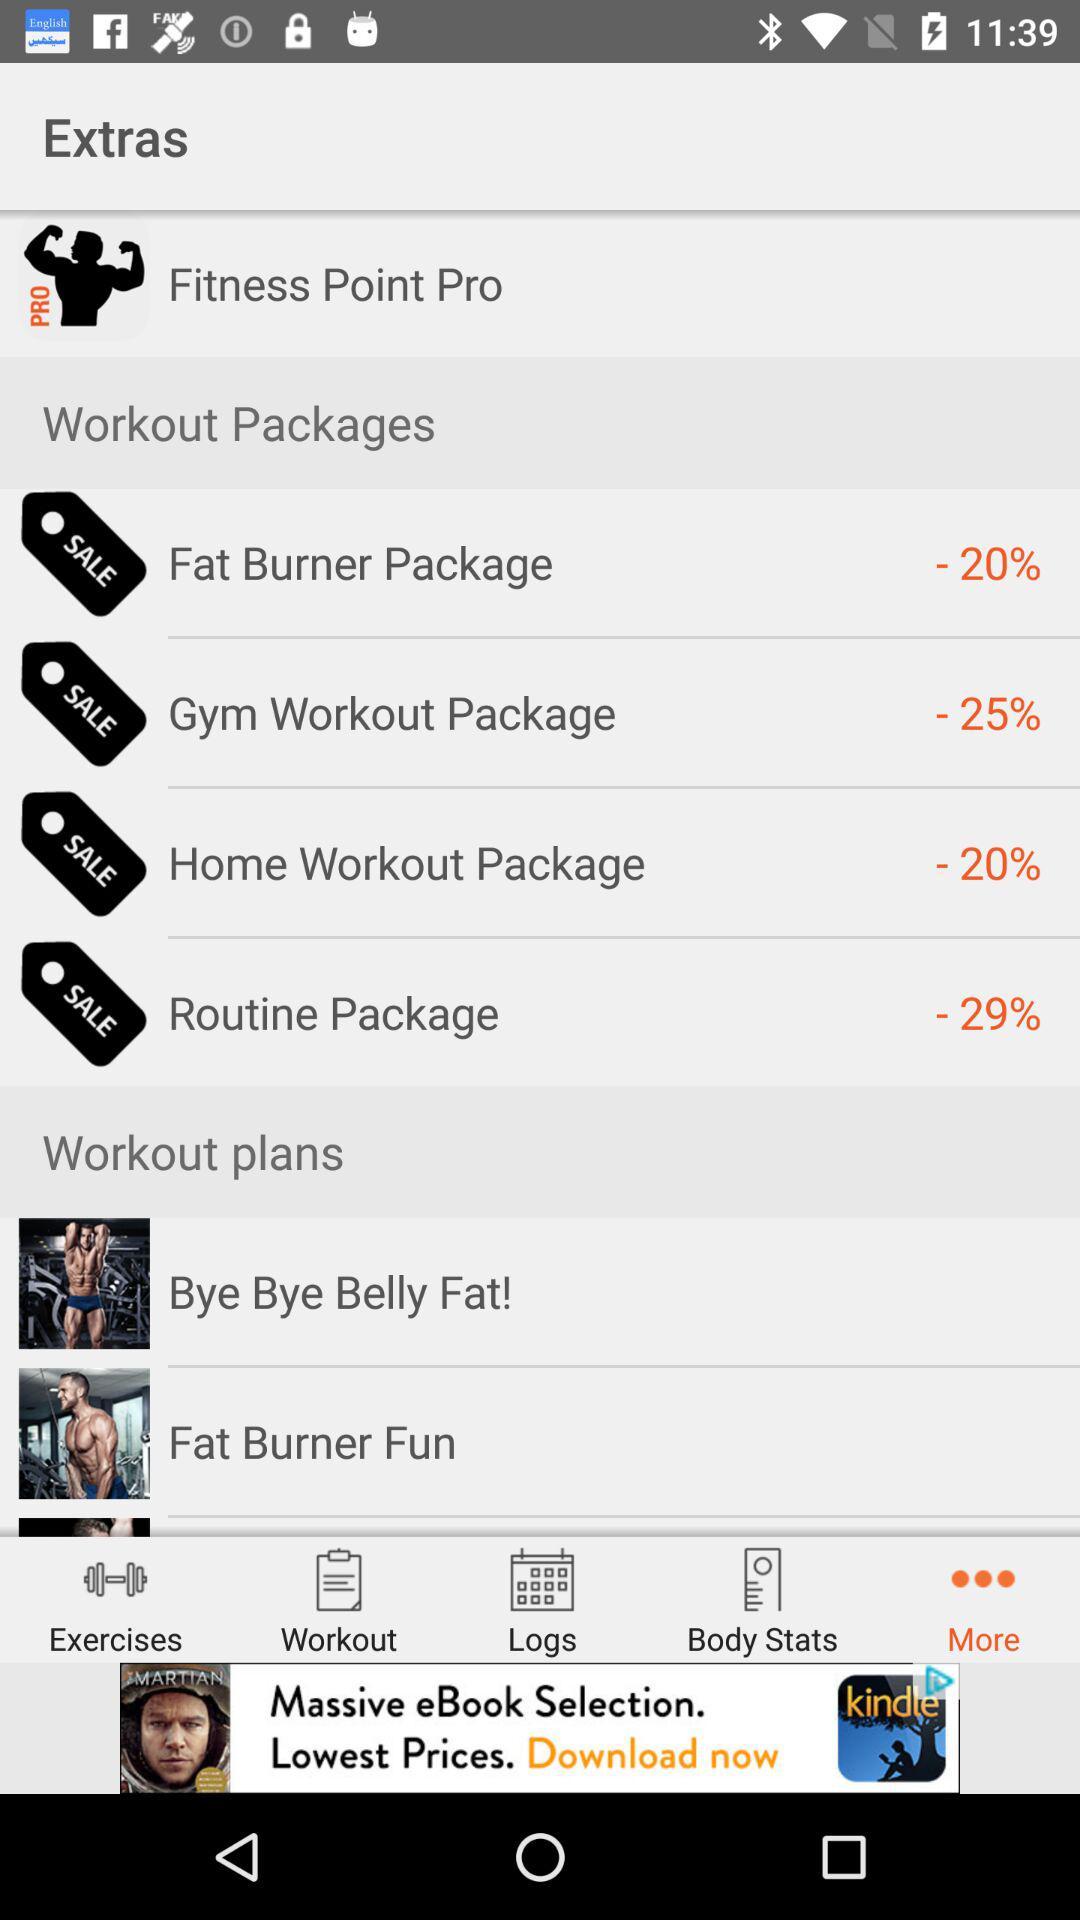What is the name of the application? The name of the application is "Fitness Point Pro". 